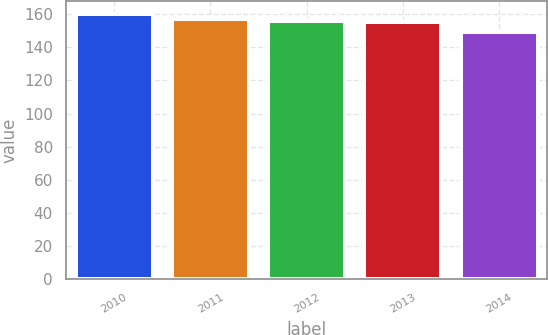Convert chart to OTSL. <chart><loc_0><loc_0><loc_500><loc_500><bar_chart><fcel>2010<fcel>2011<fcel>2012<fcel>2013<fcel>2014<nl><fcel>160<fcel>157.2<fcel>156.1<fcel>155<fcel>149<nl></chart> 